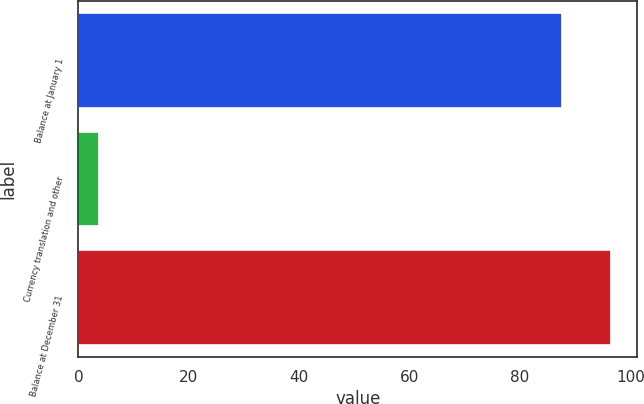Convert chart. <chart><loc_0><loc_0><loc_500><loc_500><bar_chart><fcel>Balance at January 1<fcel>Currency translation and other<fcel>Balance at December 31<nl><fcel>87.5<fcel>3.7<fcel>96.38<nl></chart> 